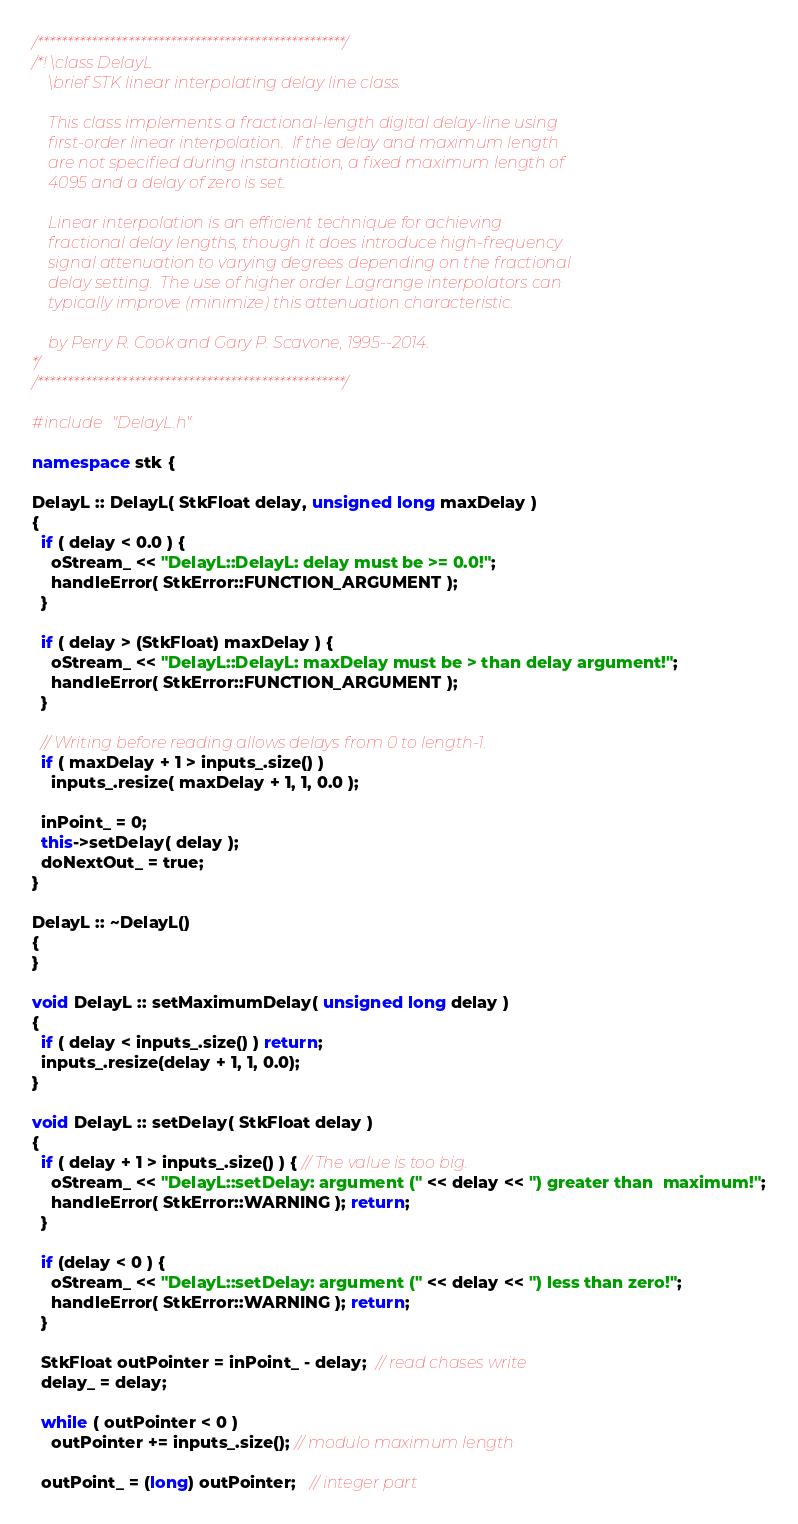Convert code to text. <code><loc_0><loc_0><loc_500><loc_500><_C++_>/***************************************************/
/*! \class DelayL
    \brief STK linear interpolating delay line class.

    This class implements a fractional-length digital delay-line using
    first-order linear interpolation.  If the delay and maximum length
    are not specified during instantiation, a fixed maximum length of
    4095 and a delay of zero is set.

    Linear interpolation is an efficient technique for achieving
    fractional delay lengths, though it does introduce high-frequency
    signal attenuation to varying degrees depending on the fractional
    delay setting.  The use of higher order Lagrange interpolators can
    typically improve (minimize) this attenuation characteristic.

    by Perry R. Cook and Gary P. Scavone, 1995--2014.
*/
/***************************************************/

#include "DelayL.h"

namespace stk {

DelayL :: DelayL( StkFloat delay, unsigned long maxDelay )
{
  if ( delay < 0.0 ) {
    oStream_ << "DelayL::DelayL: delay must be >= 0.0!";
    handleError( StkError::FUNCTION_ARGUMENT );
  }

  if ( delay > (StkFloat) maxDelay ) {
    oStream_ << "DelayL::DelayL: maxDelay must be > than delay argument!";
    handleError( StkError::FUNCTION_ARGUMENT );
  }

  // Writing before reading allows delays from 0 to length-1. 
  if ( maxDelay + 1 > inputs_.size() )
    inputs_.resize( maxDelay + 1, 1, 0.0 );

  inPoint_ = 0;
  this->setDelay( delay );
  doNextOut_ = true;
}

DelayL :: ~DelayL()
{
}

void DelayL :: setMaximumDelay( unsigned long delay )
{
  if ( delay < inputs_.size() ) return;
  inputs_.resize(delay + 1, 1, 0.0);
}

void DelayL :: setDelay( StkFloat delay )
{
  if ( delay + 1 > inputs_.size() ) { // The value is too big.
    oStream_ << "DelayL::setDelay: argument (" << delay << ") greater than  maximum!";
    handleError( StkError::WARNING ); return;
  }

  if (delay < 0 ) {
    oStream_ << "DelayL::setDelay: argument (" << delay << ") less than zero!";
    handleError( StkError::WARNING ); return;
  }

  StkFloat outPointer = inPoint_ - delay;  // read chases write
  delay_ = delay;

  while ( outPointer < 0 )
    outPointer += inputs_.size(); // modulo maximum length

  outPoint_ = (long) outPointer;   // integer part</code> 